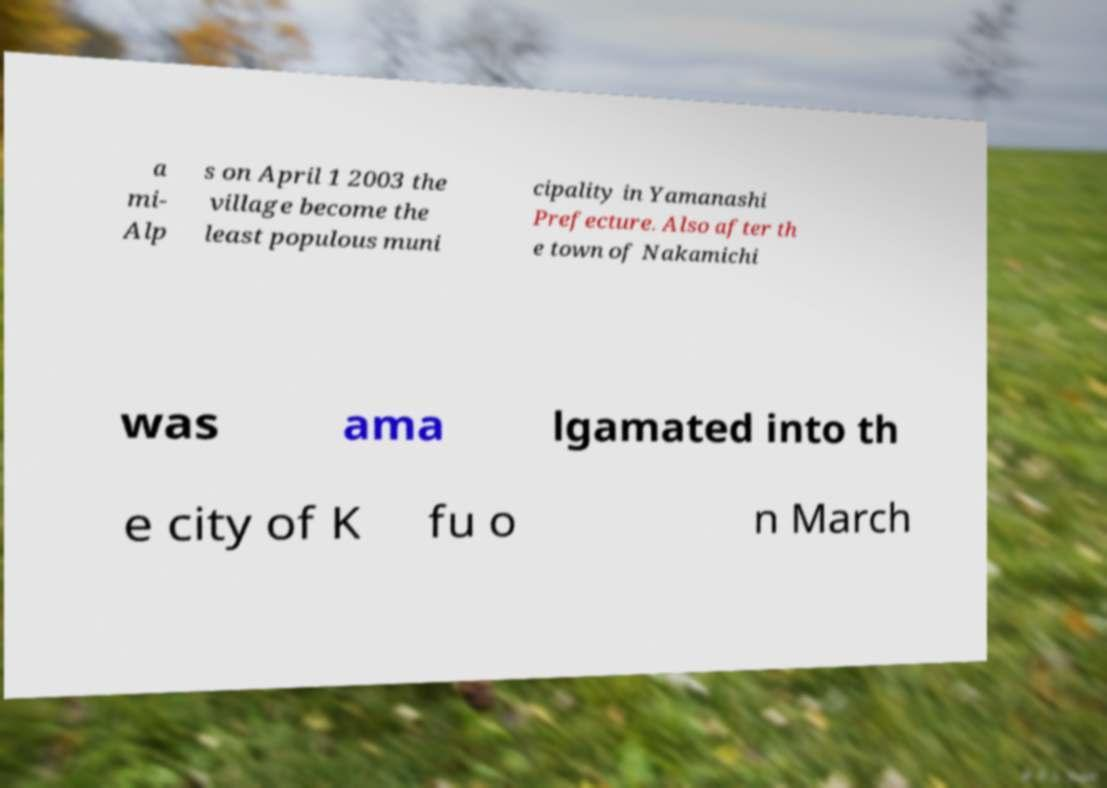Could you extract and type out the text from this image? a mi- Alp s on April 1 2003 the village become the least populous muni cipality in Yamanashi Prefecture. Also after th e town of Nakamichi was ama lgamated into th e city of K fu o n March 